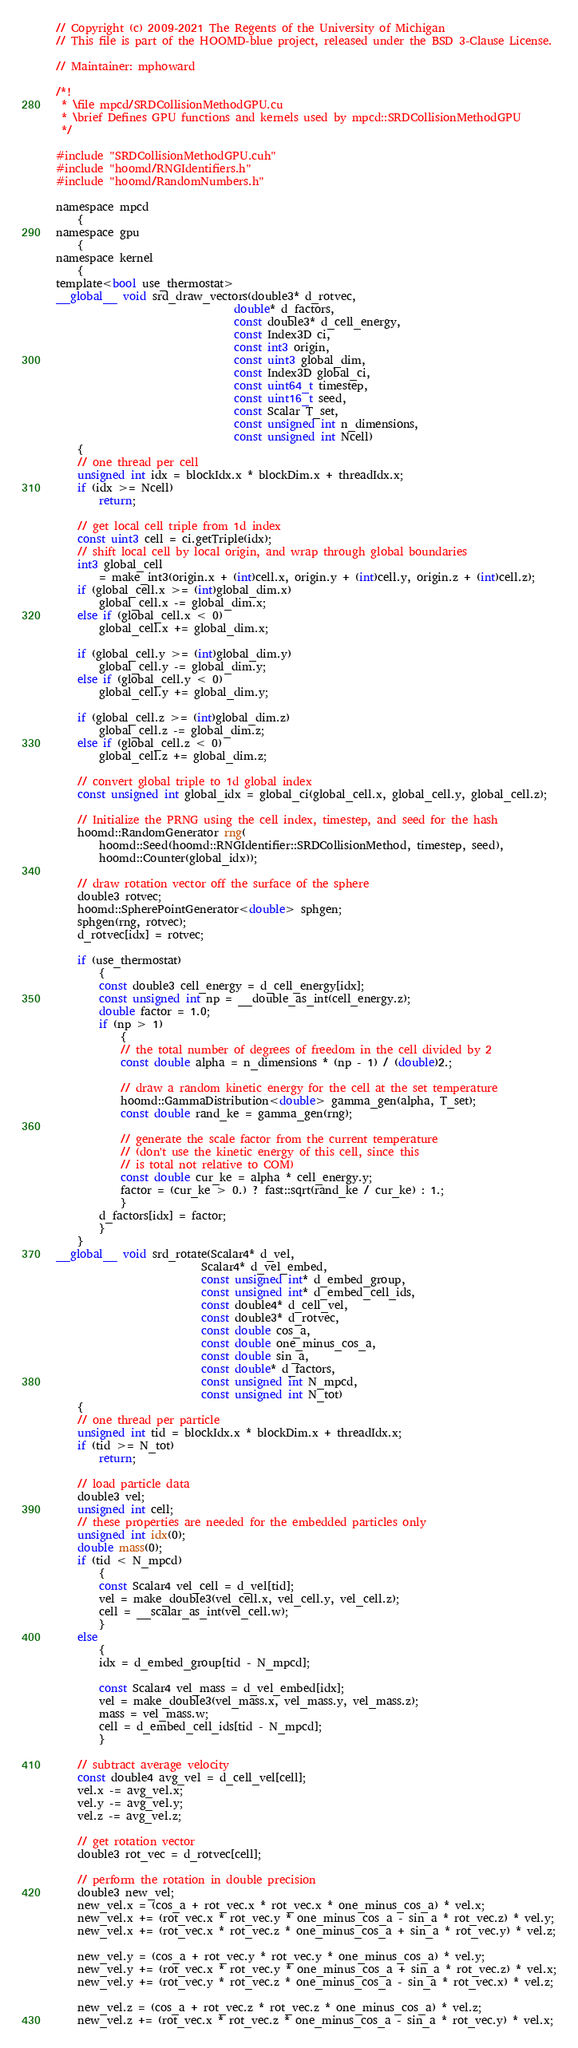Convert code to text. <code><loc_0><loc_0><loc_500><loc_500><_Cuda_>// Copyright (c) 2009-2021 The Regents of the University of Michigan
// This file is part of the HOOMD-blue project, released under the BSD 3-Clause License.

// Maintainer: mphoward

/*!
 * \file mpcd/SRDCollisionMethodGPU.cu
 * \brief Defines GPU functions and kernels used by mpcd::SRDCollisionMethodGPU
 */

#include "SRDCollisionMethodGPU.cuh"
#include "hoomd/RNGIdentifiers.h"
#include "hoomd/RandomNumbers.h"

namespace mpcd
    {
namespace gpu
    {
namespace kernel
    {
template<bool use_thermostat>
__global__ void srd_draw_vectors(double3* d_rotvec,
                                 double* d_factors,
                                 const double3* d_cell_energy,
                                 const Index3D ci,
                                 const int3 origin,
                                 const uint3 global_dim,
                                 const Index3D global_ci,
                                 const uint64_t timestep,
                                 const uint16_t seed,
                                 const Scalar T_set,
                                 const unsigned int n_dimensions,
                                 const unsigned int Ncell)
    {
    // one thread per cell
    unsigned int idx = blockIdx.x * blockDim.x + threadIdx.x;
    if (idx >= Ncell)
        return;

    // get local cell triple from 1d index
    const uint3 cell = ci.getTriple(idx);
    // shift local cell by local origin, and wrap through global boundaries
    int3 global_cell
        = make_int3(origin.x + (int)cell.x, origin.y + (int)cell.y, origin.z + (int)cell.z);
    if (global_cell.x >= (int)global_dim.x)
        global_cell.x -= global_dim.x;
    else if (global_cell.x < 0)
        global_cell.x += global_dim.x;

    if (global_cell.y >= (int)global_dim.y)
        global_cell.y -= global_dim.y;
    else if (global_cell.y < 0)
        global_cell.y += global_dim.y;

    if (global_cell.z >= (int)global_dim.z)
        global_cell.z -= global_dim.z;
    else if (global_cell.z < 0)
        global_cell.z += global_dim.z;

    // convert global triple to 1d global index
    const unsigned int global_idx = global_ci(global_cell.x, global_cell.y, global_cell.z);

    // Initialize the PRNG using the cell index, timestep, and seed for the hash
    hoomd::RandomGenerator rng(
        hoomd::Seed(hoomd::RNGIdentifier::SRDCollisionMethod, timestep, seed),
        hoomd::Counter(global_idx));

    // draw rotation vector off the surface of the sphere
    double3 rotvec;
    hoomd::SpherePointGenerator<double> sphgen;
    sphgen(rng, rotvec);
    d_rotvec[idx] = rotvec;

    if (use_thermostat)
        {
        const double3 cell_energy = d_cell_energy[idx];
        const unsigned int np = __double_as_int(cell_energy.z);
        double factor = 1.0;
        if (np > 1)
            {
            // the total number of degrees of freedom in the cell divided by 2
            const double alpha = n_dimensions * (np - 1) / (double)2.;

            // draw a random kinetic energy for the cell at the set temperature
            hoomd::GammaDistribution<double> gamma_gen(alpha, T_set);
            const double rand_ke = gamma_gen(rng);

            // generate the scale factor from the current temperature
            // (don't use the kinetic energy of this cell, since this
            // is total not relative to COM)
            const double cur_ke = alpha * cell_energy.y;
            factor = (cur_ke > 0.) ? fast::sqrt(rand_ke / cur_ke) : 1.;
            }
        d_factors[idx] = factor;
        }
    }
__global__ void srd_rotate(Scalar4* d_vel,
                           Scalar4* d_vel_embed,
                           const unsigned int* d_embed_group,
                           const unsigned int* d_embed_cell_ids,
                           const double4* d_cell_vel,
                           const double3* d_rotvec,
                           const double cos_a,
                           const double one_minus_cos_a,
                           const double sin_a,
                           const double* d_factors,
                           const unsigned int N_mpcd,
                           const unsigned int N_tot)
    {
    // one thread per particle
    unsigned int tid = blockIdx.x * blockDim.x + threadIdx.x;
    if (tid >= N_tot)
        return;

    // load particle data
    double3 vel;
    unsigned int cell;
    // these properties are needed for the embedded particles only
    unsigned int idx(0);
    double mass(0);
    if (tid < N_mpcd)
        {
        const Scalar4 vel_cell = d_vel[tid];
        vel = make_double3(vel_cell.x, vel_cell.y, vel_cell.z);
        cell = __scalar_as_int(vel_cell.w);
        }
    else
        {
        idx = d_embed_group[tid - N_mpcd];

        const Scalar4 vel_mass = d_vel_embed[idx];
        vel = make_double3(vel_mass.x, vel_mass.y, vel_mass.z);
        mass = vel_mass.w;
        cell = d_embed_cell_ids[tid - N_mpcd];
        }

    // subtract average velocity
    const double4 avg_vel = d_cell_vel[cell];
    vel.x -= avg_vel.x;
    vel.y -= avg_vel.y;
    vel.z -= avg_vel.z;

    // get rotation vector
    double3 rot_vec = d_rotvec[cell];

    // perform the rotation in double precision
    double3 new_vel;
    new_vel.x = (cos_a + rot_vec.x * rot_vec.x * one_minus_cos_a) * vel.x;
    new_vel.x += (rot_vec.x * rot_vec.y * one_minus_cos_a - sin_a * rot_vec.z) * vel.y;
    new_vel.x += (rot_vec.x * rot_vec.z * one_minus_cos_a + sin_a * rot_vec.y) * vel.z;

    new_vel.y = (cos_a + rot_vec.y * rot_vec.y * one_minus_cos_a) * vel.y;
    new_vel.y += (rot_vec.x * rot_vec.y * one_minus_cos_a + sin_a * rot_vec.z) * vel.x;
    new_vel.y += (rot_vec.y * rot_vec.z * one_minus_cos_a - sin_a * rot_vec.x) * vel.z;

    new_vel.z = (cos_a + rot_vec.z * rot_vec.z * one_minus_cos_a) * vel.z;
    new_vel.z += (rot_vec.x * rot_vec.z * one_minus_cos_a - sin_a * rot_vec.y) * vel.x;</code> 